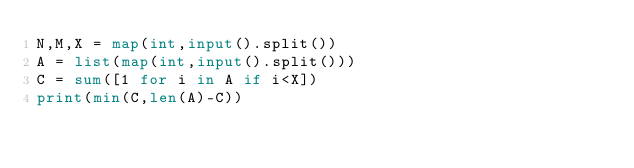<code> <loc_0><loc_0><loc_500><loc_500><_Python_>N,M,X = map(int,input().split())
A = list(map(int,input().split()))
C = sum([1 for i in A if i<X])
print(min(C,len(A)-C))</code> 